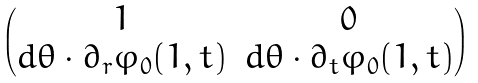Convert formula to latex. <formula><loc_0><loc_0><loc_500><loc_500>\begin{pmatrix} 1 & 0 \\ d \theta \cdot \partial _ { r } \varphi _ { 0 } ( 1 , t ) & d \theta \cdot \partial _ { t } \varphi _ { 0 } ( 1 , t ) \end{pmatrix}</formula> 